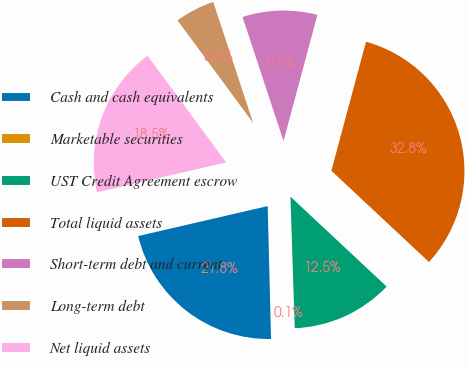Convert chart. <chart><loc_0><loc_0><loc_500><loc_500><pie_chart><fcel>Cash and cash equivalents<fcel>Marketable securities<fcel>UST Credit Agreement escrow<fcel>Total liquid assets<fcel>Short-term debt and current<fcel>Long-term debt<fcel>Net liquid assets<nl><fcel>21.78%<fcel>0.12%<fcel>12.51%<fcel>32.79%<fcel>9.25%<fcel>5.03%<fcel>18.51%<nl></chart> 